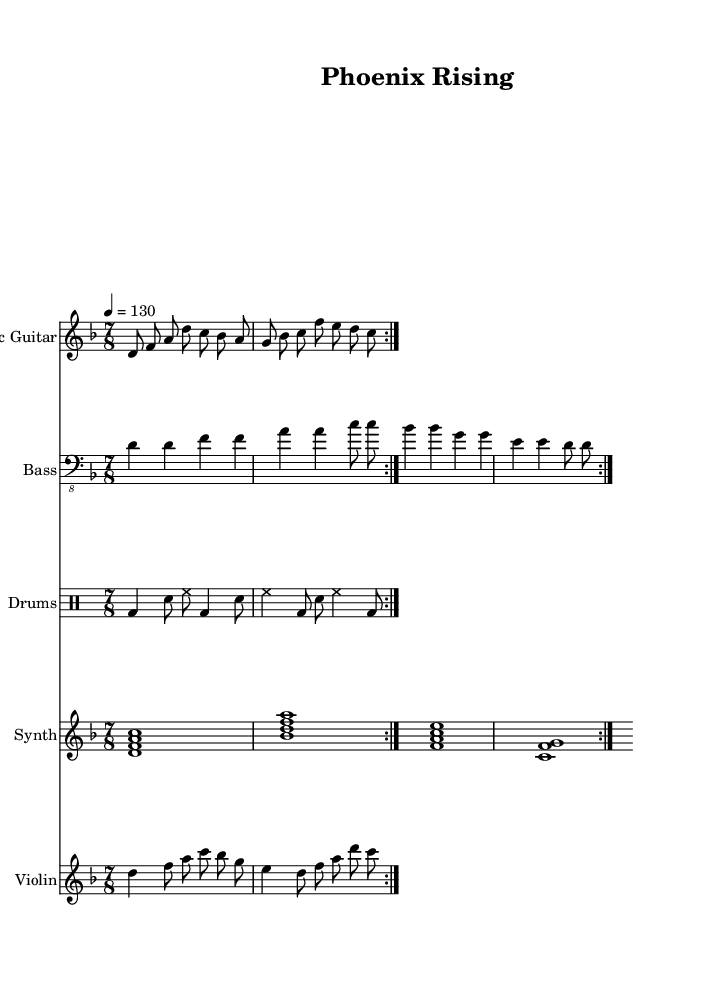What is the key signature of this music? The key signature is D minor, which includes one flat (B flat). This can be determined by looking at the key signature at the beginning of the score, indicating that the music is centered around the D major scale but begins completely in the minor mode.
Answer: D minor What is the time signature of this piece? The time signature is 7/8, which can be found right before the first measure of the music. It indicates that there are seven eighth notes in each measure, which is characteristic of certain progressive metal components.
Answer: 7/8 What is the tempo marking for this piece? The tempo marking is 130 beats per minute, indicated as "4 = 130" at the beginning of the score. This shows the conductor the speed at which the music should be played.
Answer: 130 How many measures are repeated in the electric guitar part? The electric guitar part has two measures repeated, as indicated by the text "repeat volta 2." This tells the performer to play the section two times before moving on.
Answer: 2 What is the main theme of the lyrics likely to convey based on the title "Phoenix Rising"? The title "Phoenix Rising" suggests themes of rebirth and rebuilding, likely reflecting a post-apocalyptic society's struggle and resilience. The title references the mythological bird that regenerates from ashes, an apt metaphor for recovery after tumultuous events like war.
Answer: Rebirth What kind of chords are used in the synth pad section? The synth pad section contains seventh chords indicated by the chord symbols, such as D minor 7 and B flat major 7. These particular chords provide a lush and sophisticated harmonic texture typical of progressive metal.
Answer: Seventh chords What instruments are featured in this piece? The piece features electric guitar, bass guitar, drums, synth pad, and violin. Each instrument's staff at the beginning indicates the instrumentation clearly, showing a rich combination typical in progressive metal compositions.
Answer: Electric guitar, bass guitar, drums, synth, violin 